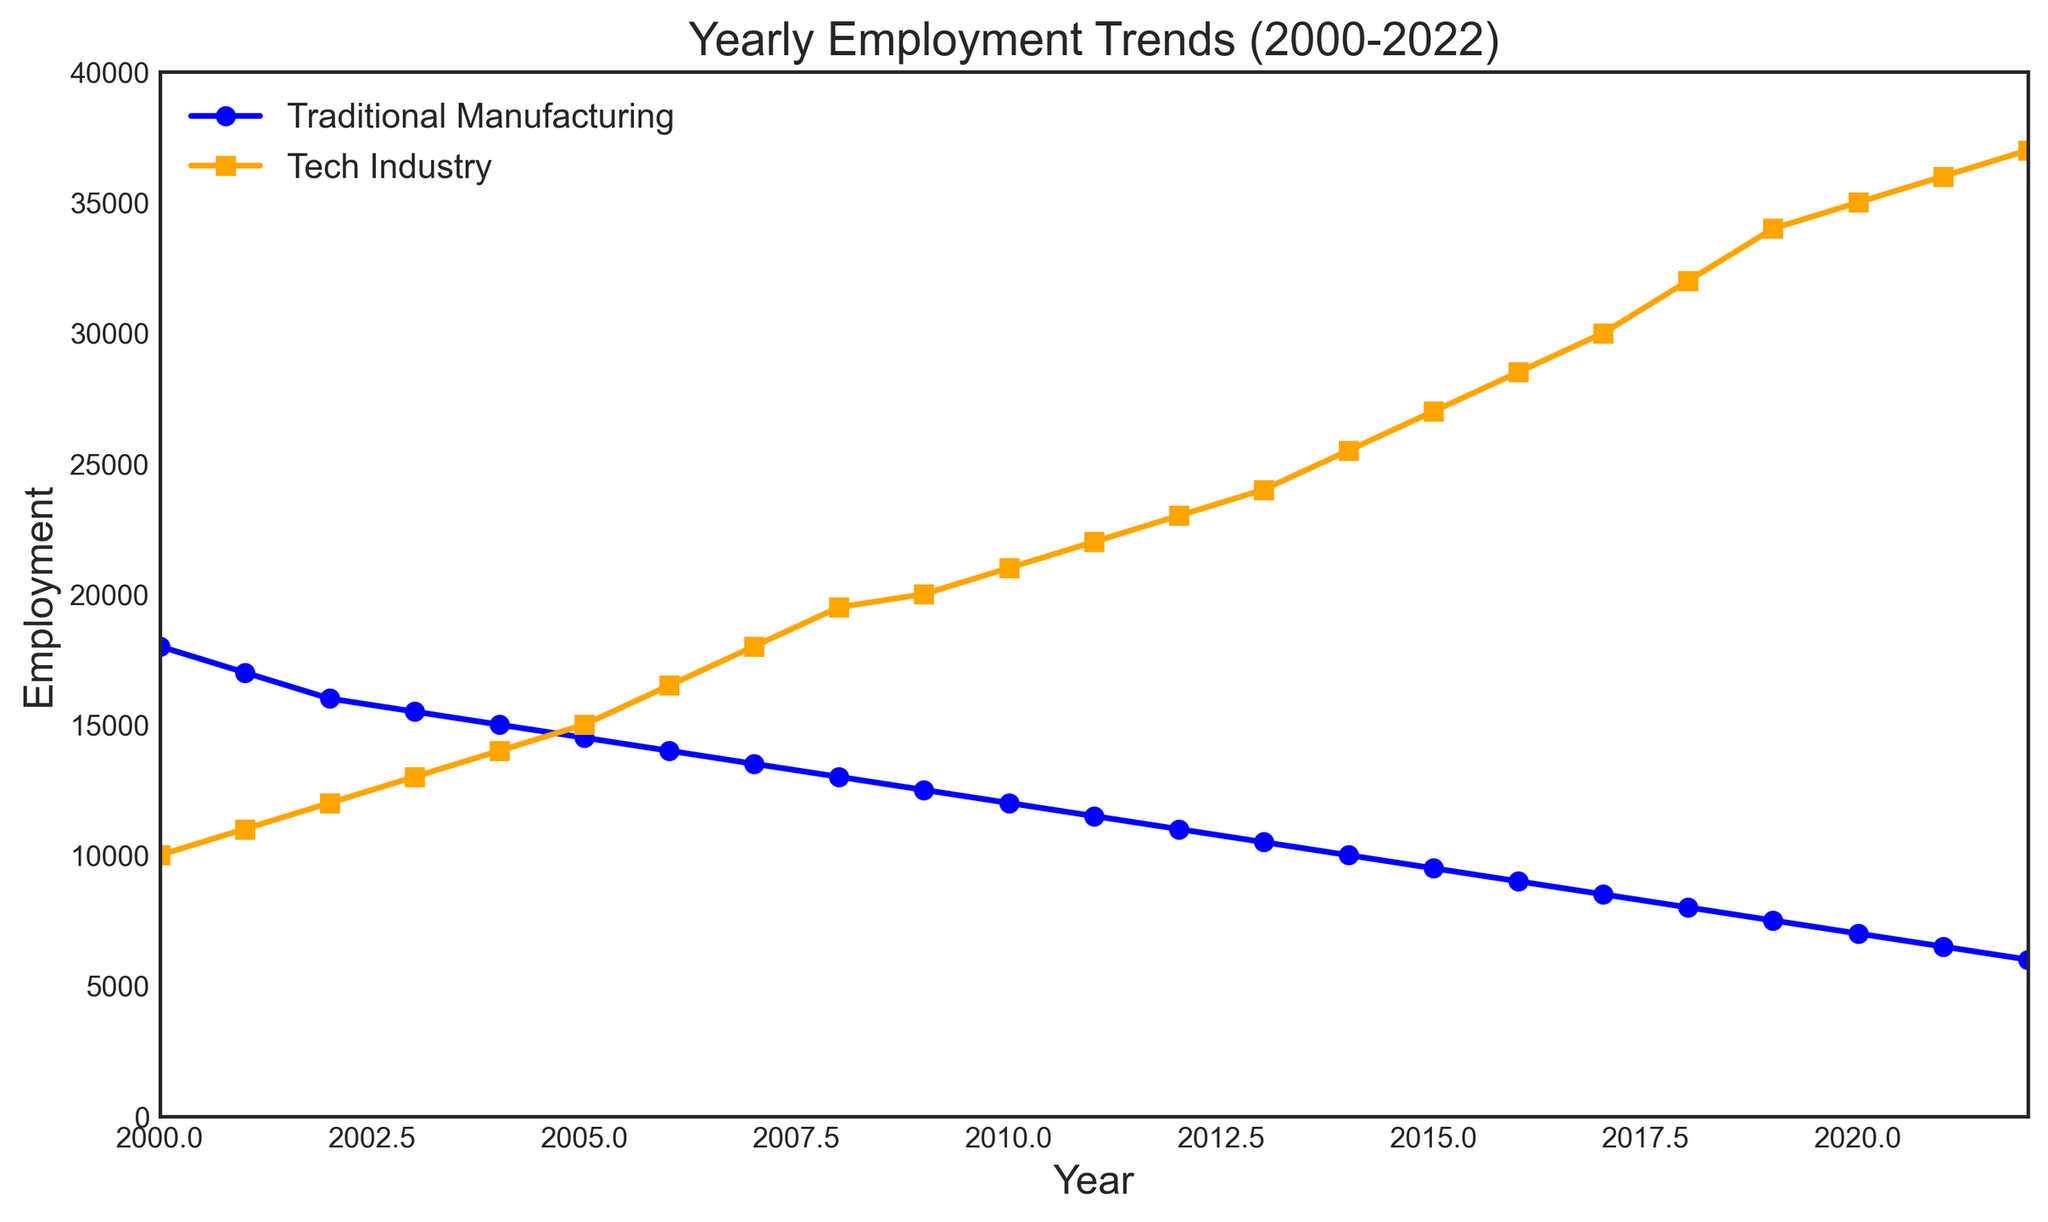What was the employment difference between Traditional Manufacturing and Tech Industry in 2000? In 2000, Traditional Manufacturing employment was 18,000 and Tech Industry employment was 10,000. The difference is 18,000 - 10,000.
Answer: 8,000 In which year did Tech Industry employment surpass Traditional Manufacturing employment? By examining the plot, we see that Tech Industry employment surpasses Traditional Manufacturing employment between 2004 and 2005.
Answer: 2004-2005 What is the average employment in the Tech Industry from 2010 to 2015? The employment numbers in the Tech Industry from 2010 to 2015 are: 21,000, 22,000, 23,000, 24,000, 25,500, 27,000. Summing these values gives 142,500 and dividing by the number of years (6) yields: 142,500 / 6.
Answer: 23,750 During which year did Traditional Manufacturing employment drop below 10,000? By observing the plot, Traditional Manufacturing employment dropped below 10,000 between 2013 and 2014.
Answer: 2013-2014 How much did Traditional Manufacturing employment decline from 2000 to 2022? Traditional Manufacturing employment in 2000 was 18,000 and in 2022 it was 6,000. The decline is 18,000 - 6,000.
Answer: 12,000 What is the employment trend for Tech Industry between 2016 and 2021? The employment in the Tech Industry from 2016 to 2021 is: 28,500, 30,000, 32,000, 34,000, 35,000, 36,000. Each year shows an increasing trend.
Answer: Increasing By how much did Tech Industry employment change from 2017 to 2018? The employment in the Tech Industry was 30,000 in 2017 and 32,000 in 2018. The change is 32,000 - 30,000.
Answer: 2,000 What is the difference in employment trends between Traditional Manufacturing and Tech Industry from 2008 to 2022? Both Traditional Manufacturing and Tech Industry have shown contrasting trends from 2008 to 2022. Traditional Manufacturing has consistently declined from 13,000 to 6,000, while the Tech Industry has consistently increased from 19,500 to 37,000.
Answer: Traditional Manufacturing declined, Tech Industry increased 